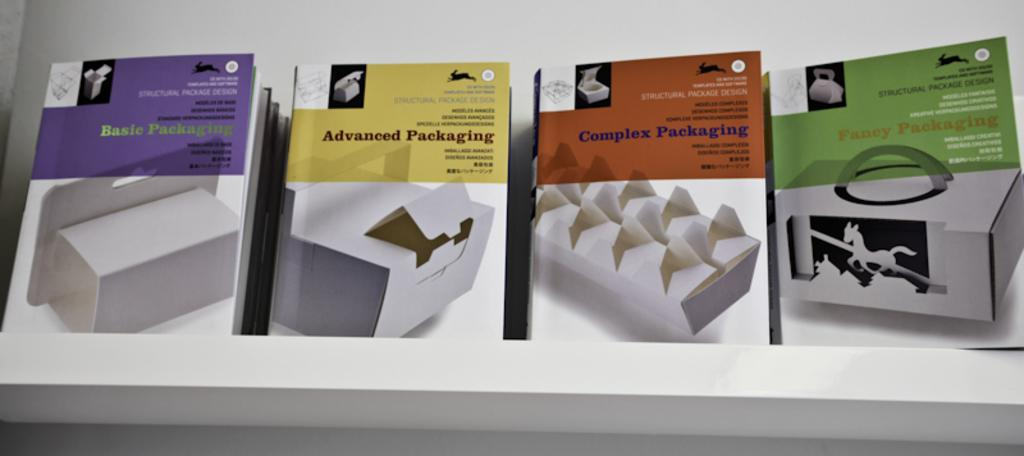<image>
Provide a brief description of the given image. A row of boxes have basic, advanced, and complex packaging printed on the fronts. 